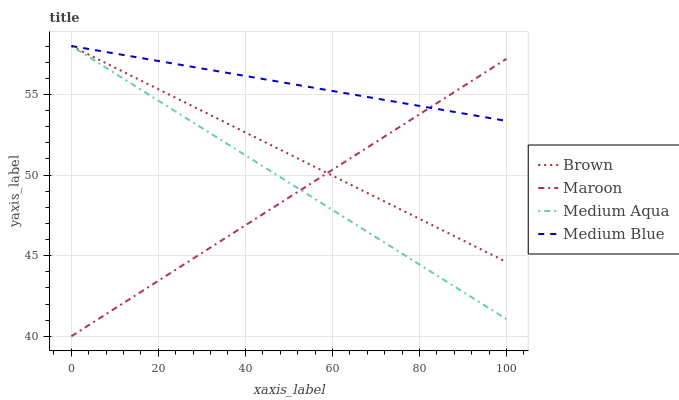Does Maroon have the minimum area under the curve?
Answer yes or no. Yes. Does Medium Blue have the maximum area under the curve?
Answer yes or no. Yes. Does Medium Aqua have the minimum area under the curve?
Answer yes or no. No. Does Medium Aqua have the maximum area under the curve?
Answer yes or no. No. Is Medium Blue the smoothest?
Answer yes or no. Yes. Is Maroon the roughest?
Answer yes or no. Yes. Is Medium Aqua the smoothest?
Answer yes or no. No. Is Medium Aqua the roughest?
Answer yes or no. No. Does Maroon have the lowest value?
Answer yes or no. Yes. Does Medium Aqua have the lowest value?
Answer yes or no. No. Does Medium Blue have the highest value?
Answer yes or no. Yes. Does Maroon have the highest value?
Answer yes or no. No. Does Medium Aqua intersect Brown?
Answer yes or no. Yes. Is Medium Aqua less than Brown?
Answer yes or no. No. Is Medium Aqua greater than Brown?
Answer yes or no. No. 